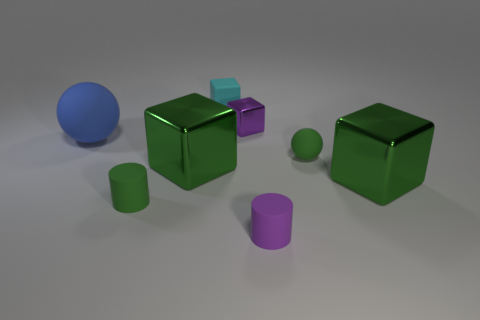How many other matte objects have the same shape as the tiny purple rubber thing?
Provide a succinct answer. 1. What size is the green thing that is the same shape as the blue object?
Offer a terse response. Small. There is a tiny thing that is the same shape as the big blue thing; what is its material?
Offer a very short reply. Rubber. How many matte cylinders have the same color as the tiny shiny block?
Offer a very short reply. 1. What is the color of the matte cube that is the same size as the purple cylinder?
Your response must be concise. Cyan. Is the small purple object that is behind the big blue matte thing made of the same material as the cyan object?
Your response must be concise. No. How big is the matte thing that is both left of the tiny rubber block and right of the blue rubber thing?
Provide a succinct answer. Small. How big is the metal block on the left side of the cyan thing?
Offer a terse response. Large. The other object that is the same color as the small metallic thing is what shape?
Give a very brief answer. Cylinder. The purple object behind the sphere that is in front of the large sphere that is behind the small green cylinder is what shape?
Keep it short and to the point. Cube. 